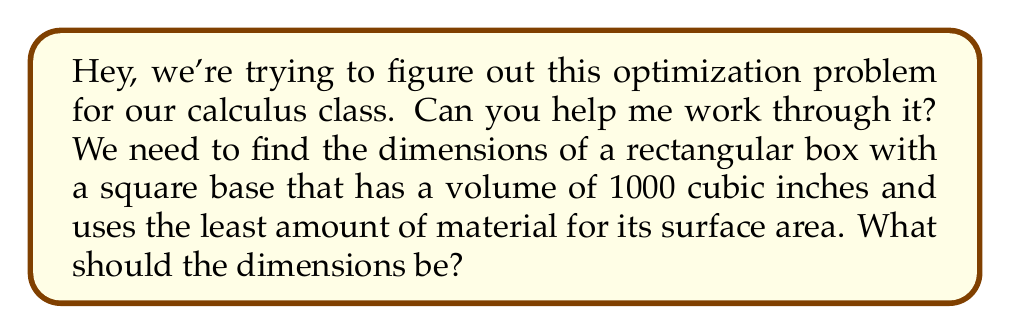Can you solve this math problem? Sure, let's tackle this together! Here's how we can approach it:

1) Let's define our variables:
   Let $x$ be the length of the square base
   Let $h$ be the height of the box

2) We know the volume is 1000 cubic inches, so:
   $$ x^2h = 1000 $$

3) The surface area (SA) of the box is what we want to minimize:
   $$ SA = x^2 + 4xh $$

4) We can express $h$ in terms of $x$ using the volume equation:
   $$ h = \frac{1000}{x^2} $$

5) Now, let's substitute this into our surface area equation:
   $$ SA = x^2 + 4x(\frac{1000}{x^2}) = x^2 + \frac{4000}{x} $$

6) To find the minimum, we need to differentiate SA with respect to x and set it to zero:
   $$ \frac{dSA}{dx} = 2x - \frac{4000}{x^2} = 0 $$

7) Solving this equation:
   $$ 2x^3 = 4000 $$
   $$ x^3 = 2000 $$
   $$ x = \sqrt[3]{2000} \approx 12.6 $$

8) Now we can find h:
   $$ h = \frac{1000}{x^2} = \frac{1000}{(\sqrt[3]{2000})^2} = \frac{\sqrt[3]{2000}}{2} \approx 6.3 $$

9) To confirm this is a minimum, we could check the second derivative is positive at this point.
Answer: $x \approx 12.6$ inches, $h \approx 6.3$ inches 